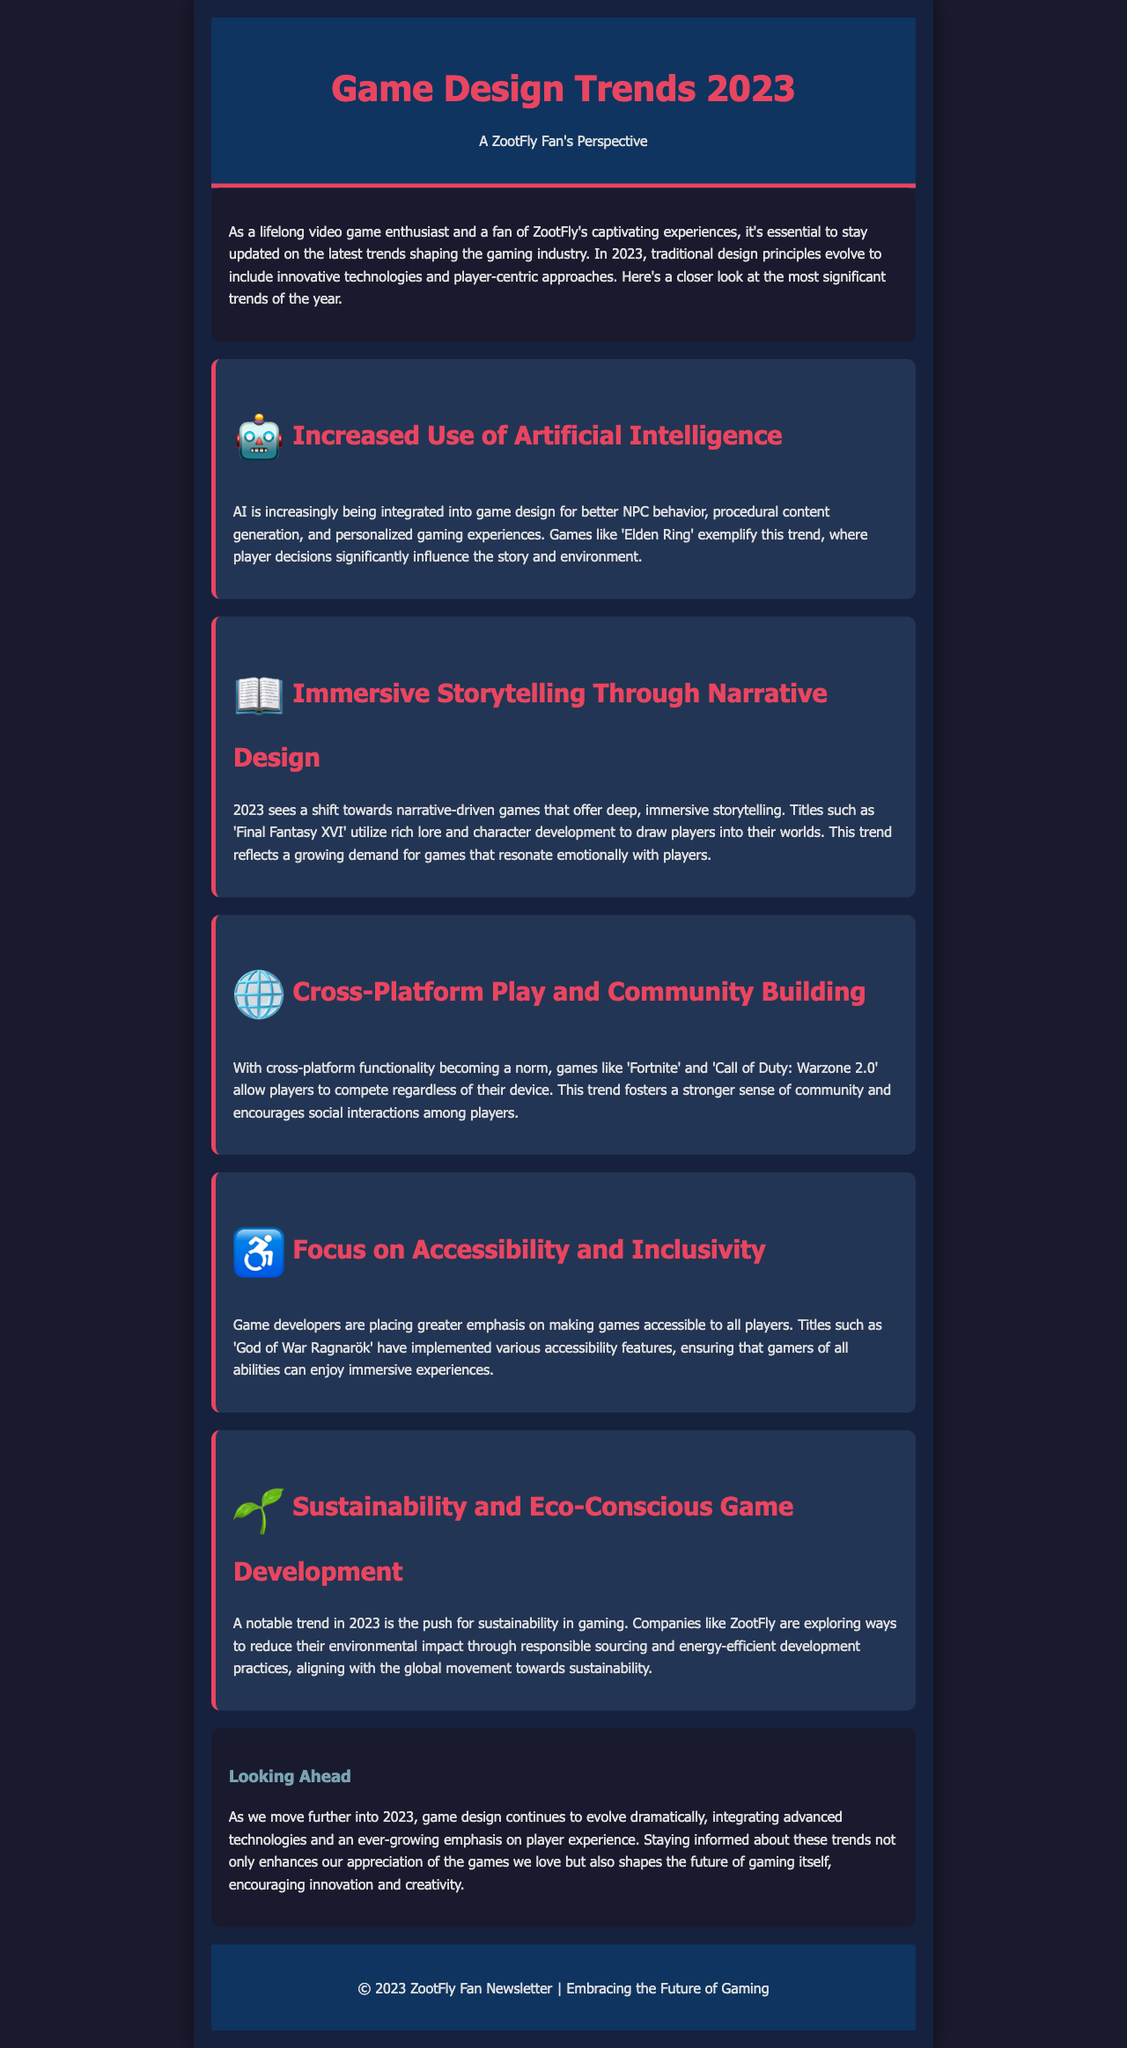What is the title of the newsletter? The title of the newsletter is specified in the header section, which is "Game Design Trends 2023".
Answer: Game Design Trends 2023 Who is the newsletter aimed at? The introduction mentions that it is aimed at a "ZootFly Fan's Perspective," indicating the target audience.
Answer: ZootFly Fan Name one game mentioned that exemplifies increased use of artificial intelligence. The document notes 'Elden Ring' as a game that showcases the trend of AI integration in game design.
Answer: Elden Ring What year does the newsletter focus on for game design trends? The title of the newsletter indicates that the trends discussed pertain to the year "2023".
Answer: 2023 Which trend focuses on environmental consciousness in game development? The section discusses "Sustainability and Eco-Conscious Game Development," which addresses this issue.
Answer: Sustainability and Eco-Conscious Game Development How are accessibility features highlighted in the newsletter? The document specifies that 'God of War Ragnarök' has implemented various accessibility features, showcasing the focus on inclusivity.
Answer: God of War Ragnarök What is one of the benefits of cross-platform play mentioned? The newsletter states that cross-platform functionality fosters a stronger sense of community among players.
Answer: Stronger sense of community List one game that emphasizes immersive storytelling. The document mentions 'Final Fantasy XVI' as a title that offers deep, immersive storytelling experiences.
Answer: Final Fantasy XVI 